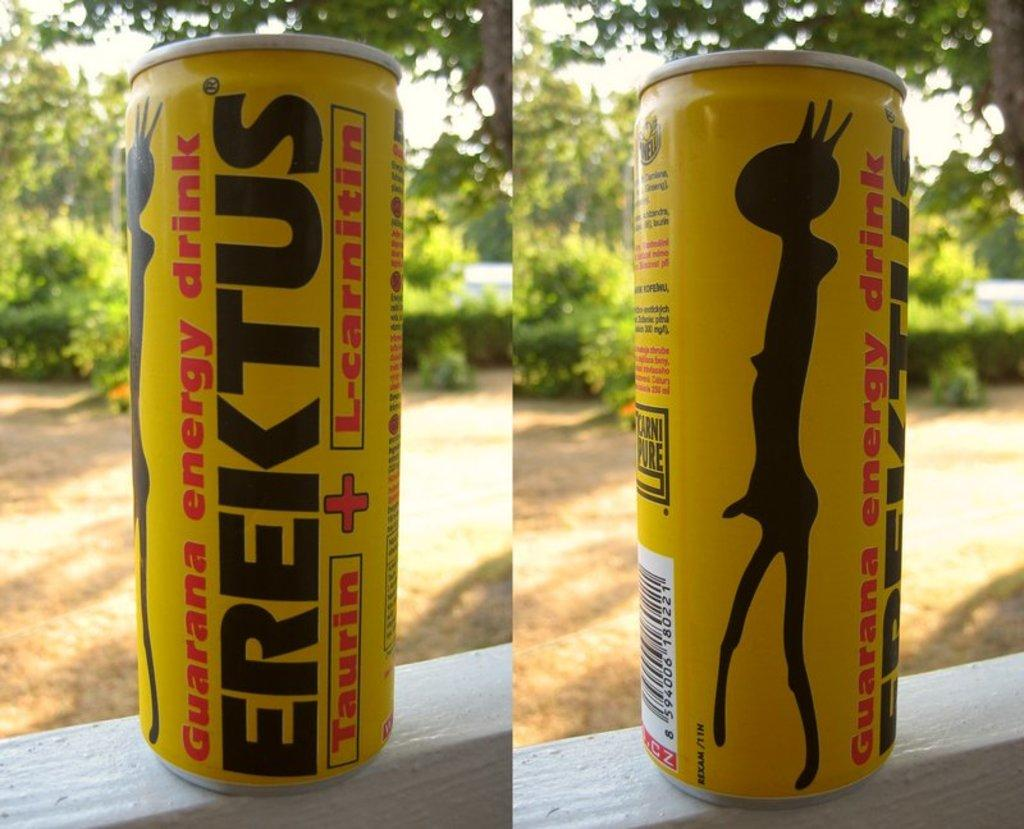<image>
Present a compact description of the photo's key features. a can that has the word erektus on it 